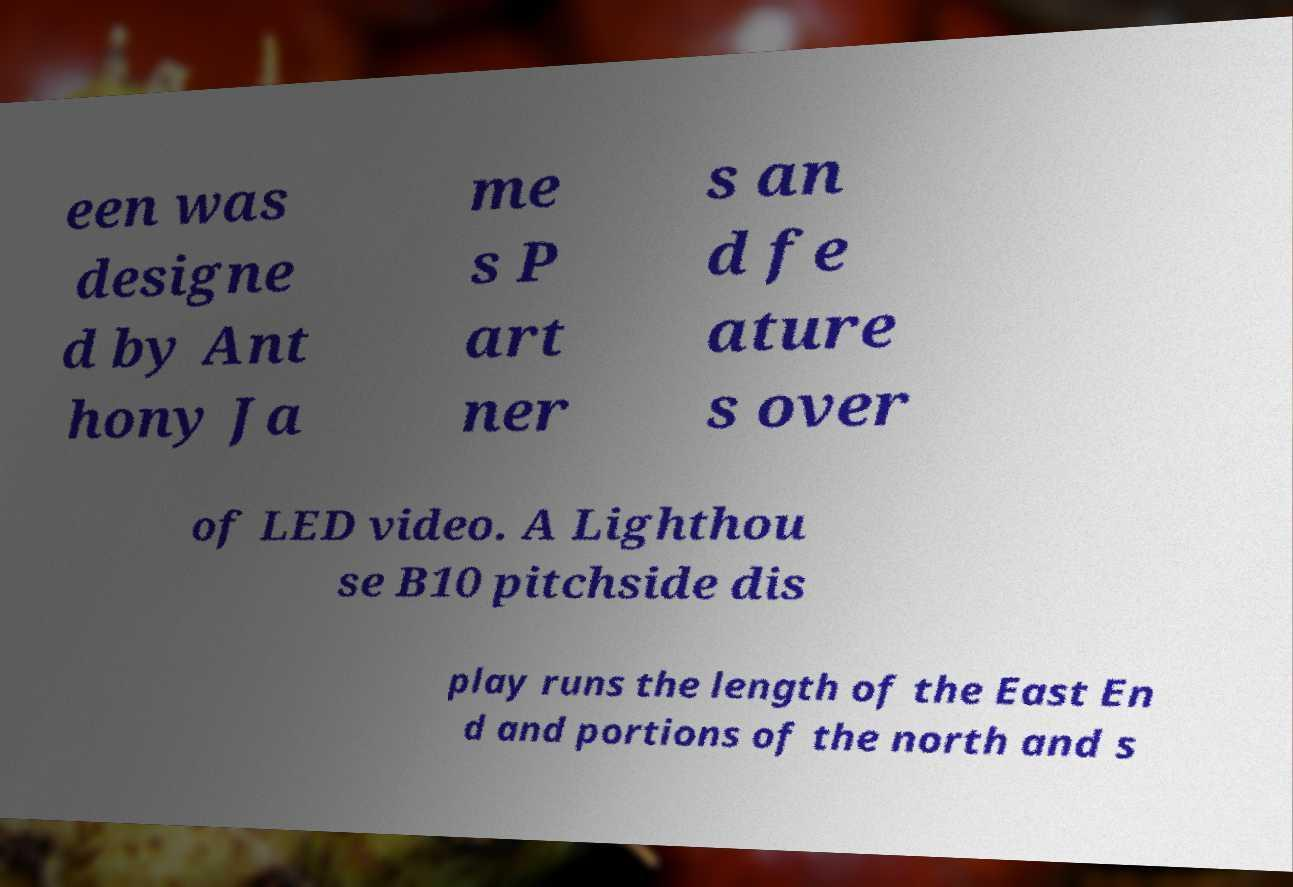Could you extract and type out the text from this image? een was designe d by Ant hony Ja me s P art ner s an d fe ature s over of LED video. A Lighthou se B10 pitchside dis play runs the length of the East En d and portions of the north and s 